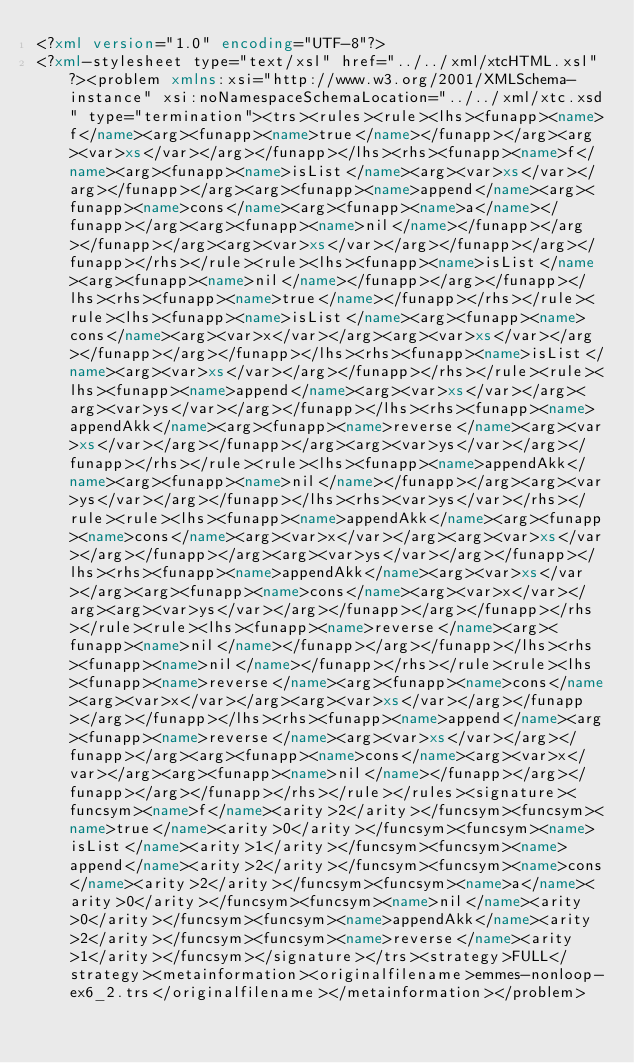<code> <loc_0><loc_0><loc_500><loc_500><_XML_><?xml version="1.0" encoding="UTF-8"?>
<?xml-stylesheet type="text/xsl" href="../../xml/xtcHTML.xsl"?><problem xmlns:xsi="http://www.w3.org/2001/XMLSchema-instance" xsi:noNamespaceSchemaLocation="../../xml/xtc.xsd" type="termination"><trs><rules><rule><lhs><funapp><name>f</name><arg><funapp><name>true</name></funapp></arg><arg><var>xs</var></arg></funapp></lhs><rhs><funapp><name>f</name><arg><funapp><name>isList</name><arg><var>xs</var></arg></funapp></arg><arg><funapp><name>append</name><arg><funapp><name>cons</name><arg><funapp><name>a</name></funapp></arg><arg><funapp><name>nil</name></funapp></arg></funapp></arg><arg><var>xs</var></arg></funapp></arg></funapp></rhs></rule><rule><lhs><funapp><name>isList</name><arg><funapp><name>nil</name></funapp></arg></funapp></lhs><rhs><funapp><name>true</name></funapp></rhs></rule><rule><lhs><funapp><name>isList</name><arg><funapp><name>cons</name><arg><var>x</var></arg><arg><var>xs</var></arg></funapp></arg></funapp></lhs><rhs><funapp><name>isList</name><arg><var>xs</var></arg></funapp></rhs></rule><rule><lhs><funapp><name>append</name><arg><var>xs</var></arg><arg><var>ys</var></arg></funapp></lhs><rhs><funapp><name>appendAkk</name><arg><funapp><name>reverse</name><arg><var>xs</var></arg></funapp></arg><arg><var>ys</var></arg></funapp></rhs></rule><rule><lhs><funapp><name>appendAkk</name><arg><funapp><name>nil</name></funapp></arg><arg><var>ys</var></arg></funapp></lhs><rhs><var>ys</var></rhs></rule><rule><lhs><funapp><name>appendAkk</name><arg><funapp><name>cons</name><arg><var>x</var></arg><arg><var>xs</var></arg></funapp></arg><arg><var>ys</var></arg></funapp></lhs><rhs><funapp><name>appendAkk</name><arg><var>xs</var></arg><arg><funapp><name>cons</name><arg><var>x</var></arg><arg><var>ys</var></arg></funapp></arg></funapp></rhs></rule><rule><lhs><funapp><name>reverse</name><arg><funapp><name>nil</name></funapp></arg></funapp></lhs><rhs><funapp><name>nil</name></funapp></rhs></rule><rule><lhs><funapp><name>reverse</name><arg><funapp><name>cons</name><arg><var>x</var></arg><arg><var>xs</var></arg></funapp></arg></funapp></lhs><rhs><funapp><name>append</name><arg><funapp><name>reverse</name><arg><var>xs</var></arg></funapp></arg><arg><funapp><name>cons</name><arg><var>x</var></arg><arg><funapp><name>nil</name></funapp></arg></funapp></arg></funapp></rhs></rule></rules><signature><funcsym><name>f</name><arity>2</arity></funcsym><funcsym><name>true</name><arity>0</arity></funcsym><funcsym><name>isList</name><arity>1</arity></funcsym><funcsym><name>append</name><arity>2</arity></funcsym><funcsym><name>cons</name><arity>2</arity></funcsym><funcsym><name>a</name><arity>0</arity></funcsym><funcsym><name>nil</name><arity>0</arity></funcsym><funcsym><name>appendAkk</name><arity>2</arity></funcsym><funcsym><name>reverse</name><arity>1</arity></funcsym></signature></trs><strategy>FULL</strategy><metainformation><originalfilename>emmes-nonloop-ex6_2.trs</originalfilename></metainformation></problem></code> 